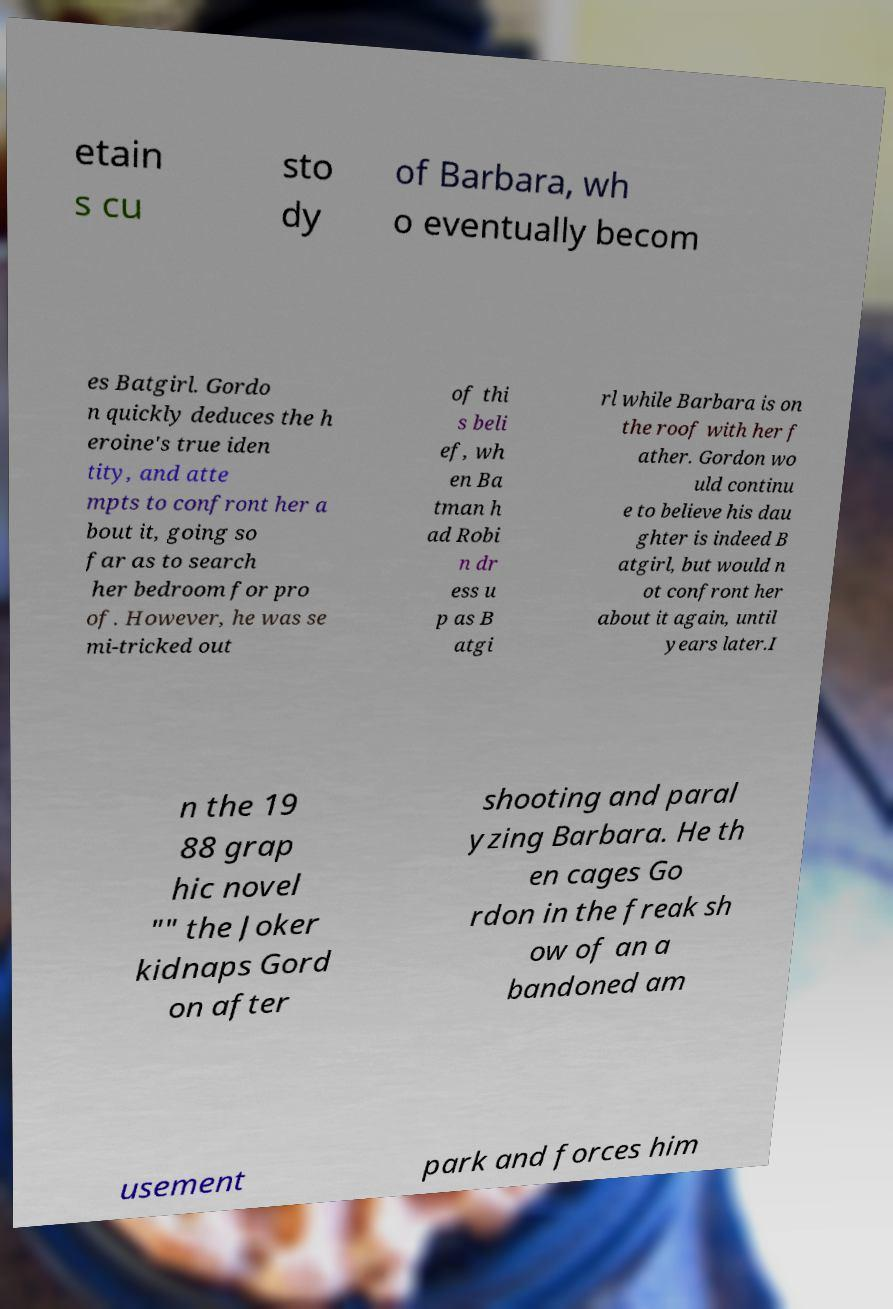What messages or text are displayed in this image? I need them in a readable, typed format. etain s cu sto dy of Barbara, wh o eventually becom es Batgirl. Gordo n quickly deduces the h eroine's true iden tity, and atte mpts to confront her a bout it, going so far as to search her bedroom for pro of. However, he was se mi-tricked out of thi s beli ef, wh en Ba tman h ad Robi n dr ess u p as B atgi rl while Barbara is on the roof with her f ather. Gordon wo uld continu e to believe his dau ghter is indeed B atgirl, but would n ot confront her about it again, until years later.I n the 19 88 grap hic novel "" the Joker kidnaps Gord on after shooting and paral yzing Barbara. He th en cages Go rdon in the freak sh ow of an a bandoned am usement park and forces him 